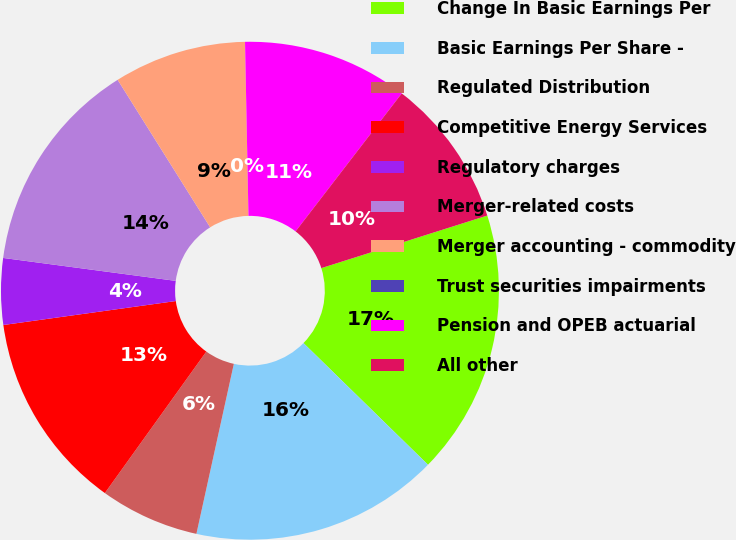<chart> <loc_0><loc_0><loc_500><loc_500><pie_chart><fcel>Change In Basic Earnings Per<fcel>Basic Earnings Per Share -<fcel>Regulated Distribution<fcel>Competitive Energy Services<fcel>Regulatory charges<fcel>Merger-related costs<fcel>Merger accounting - commodity<fcel>Trust securities impairments<fcel>Pension and OPEB actuarial<fcel>All other<nl><fcel>17.2%<fcel>16.13%<fcel>6.45%<fcel>12.9%<fcel>4.3%<fcel>13.98%<fcel>8.6%<fcel>0.0%<fcel>10.75%<fcel>9.68%<nl></chart> 